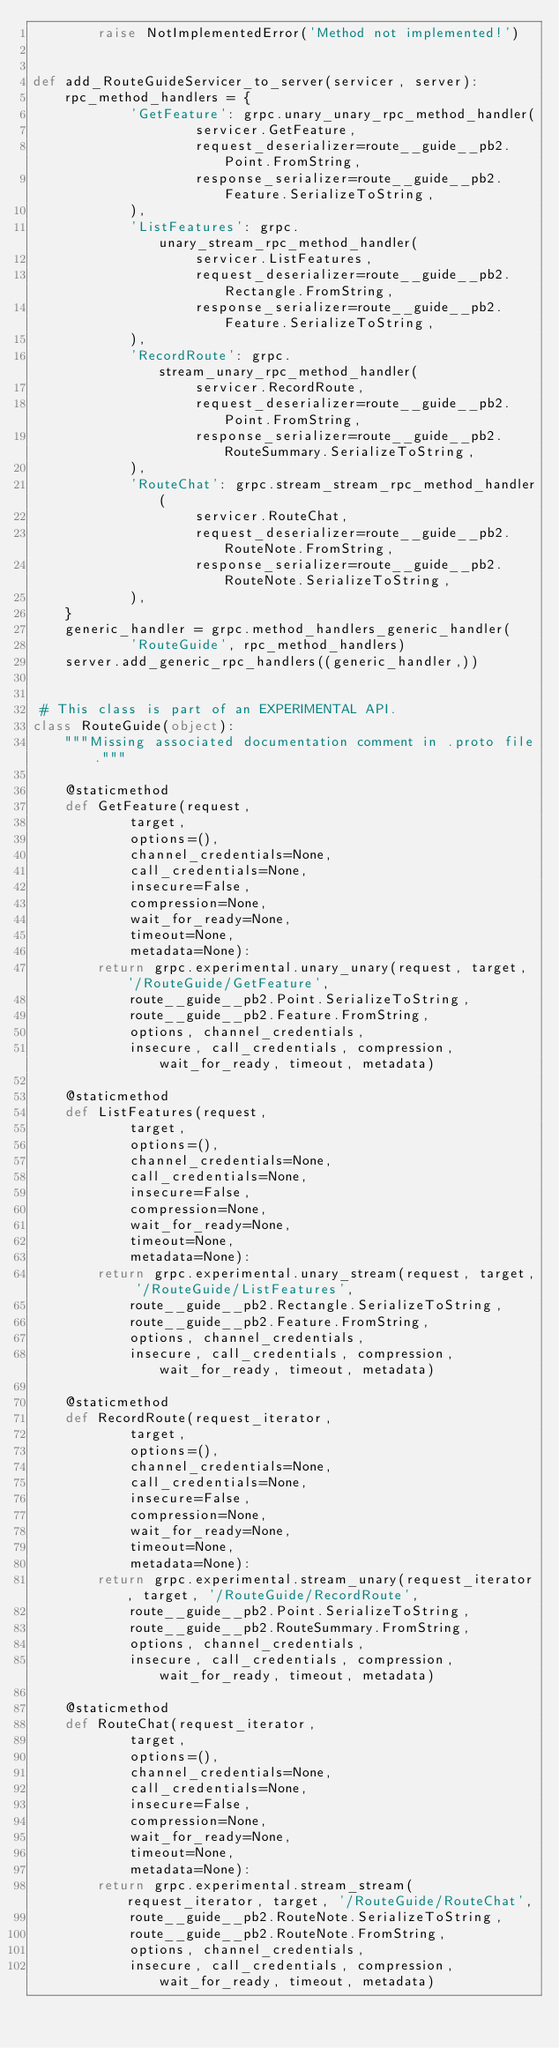Convert code to text. <code><loc_0><loc_0><loc_500><loc_500><_Python_>        raise NotImplementedError('Method not implemented!')


def add_RouteGuideServicer_to_server(servicer, server):
    rpc_method_handlers = {
            'GetFeature': grpc.unary_unary_rpc_method_handler(
                    servicer.GetFeature,
                    request_deserializer=route__guide__pb2.Point.FromString,
                    response_serializer=route__guide__pb2.Feature.SerializeToString,
            ),
            'ListFeatures': grpc.unary_stream_rpc_method_handler(
                    servicer.ListFeatures,
                    request_deserializer=route__guide__pb2.Rectangle.FromString,
                    response_serializer=route__guide__pb2.Feature.SerializeToString,
            ),
            'RecordRoute': grpc.stream_unary_rpc_method_handler(
                    servicer.RecordRoute,
                    request_deserializer=route__guide__pb2.Point.FromString,
                    response_serializer=route__guide__pb2.RouteSummary.SerializeToString,
            ),
            'RouteChat': grpc.stream_stream_rpc_method_handler(
                    servicer.RouteChat,
                    request_deserializer=route__guide__pb2.RouteNote.FromString,
                    response_serializer=route__guide__pb2.RouteNote.SerializeToString,
            ),
    }
    generic_handler = grpc.method_handlers_generic_handler(
            'RouteGuide', rpc_method_handlers)
    server.add_generic_rpc_handlers((generic_handler,))


 # This class is part of an EXPERIMENTAL API.
class RouteGuide(object):
    """Missing associated documentation comment in .proto file."""

    @staticmethod
    def GetFeature(request,
            target,
            options=(),
            channel_credentials=None,
            call_credentials=None,
            insecure=False,
            compression=None,
            wait_for_ready=None,
            timeout=None,
            metadata=None):
        return grpc.experimental.unary_unary(request, target, '/RouteGuide/GetFeature',
            route__guide__pb2.Point.SerializeToString,
            route__guide__pb2.Feature.FromString,
            options, channel_credentials,
            insecure, call_credentials, compression, wait_for_ready, timeout, metadata)

    @staticmethod
    def ListFeatures(request,
            target,
            options=(),
            channel_credentials=None,
            call_credentials=None,
            insecure=False,
            compression=None,
            wait_for_ready=None,
            timeout=None,
            metadata=None):
        return grpc.experimental.unary_stream(request, target, '/RouteGuide/ListFeatures',
            route__guide__pb2.Rectangle.SerializeToString,
            route__guide__pb2.Feature.FromString,
            options, channel_credentials,
            insecure, call_credentials, compression, wait_for_ready, timeout, metadata)

    @staticmethod
    def RecordRoute(request_iterator,
            target,
            options=(),
            channel_credentials=None,
            call_credentials=None,
            insecure=False,
            compression=None,
            wait_for_ready=None,
            timeout=None,
            metadata=None):
        return grpc.experimental.stream_unary(request_iterator, target, '/RouteGuide/RecordRoute',
            route__guide__pb2.Point.SerializeToString,
            route__guide__pb2.RouteSummary.FromString,
            options, channel_credentials,
            insecure, call_credentials, compression, wait_for_ready, timeout, metadata)

    @staticmethod
    def RouteChat(request_iterator,
            target,
            options=(),
            channel_credentials=None,
            call_credentials=None,
            insecure=False,
            compression=None,
            wait_for_ready=None,
            timeout=None,
            metadata=None):
        return grpc.experimental.stream_stream(request_iterator, target, '/RouteGuide/RouteChat',
            route__guide__pb2.RouteNote.SerializeToString,
            route__guide__pb2.RouteNote.FromString,
            options, channel_credentials,
            insecure, call_credentials, compression, wait_for_ready, timeout, metadata)
</code> 